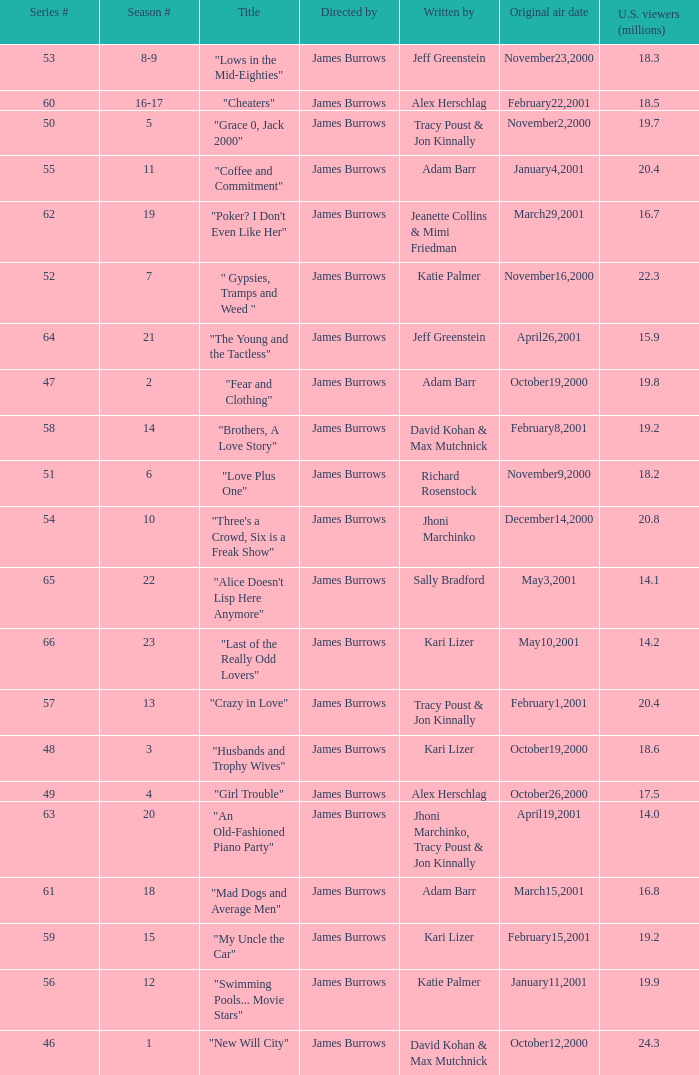Who wrote episode 23 in the season? Kari Lizer. 